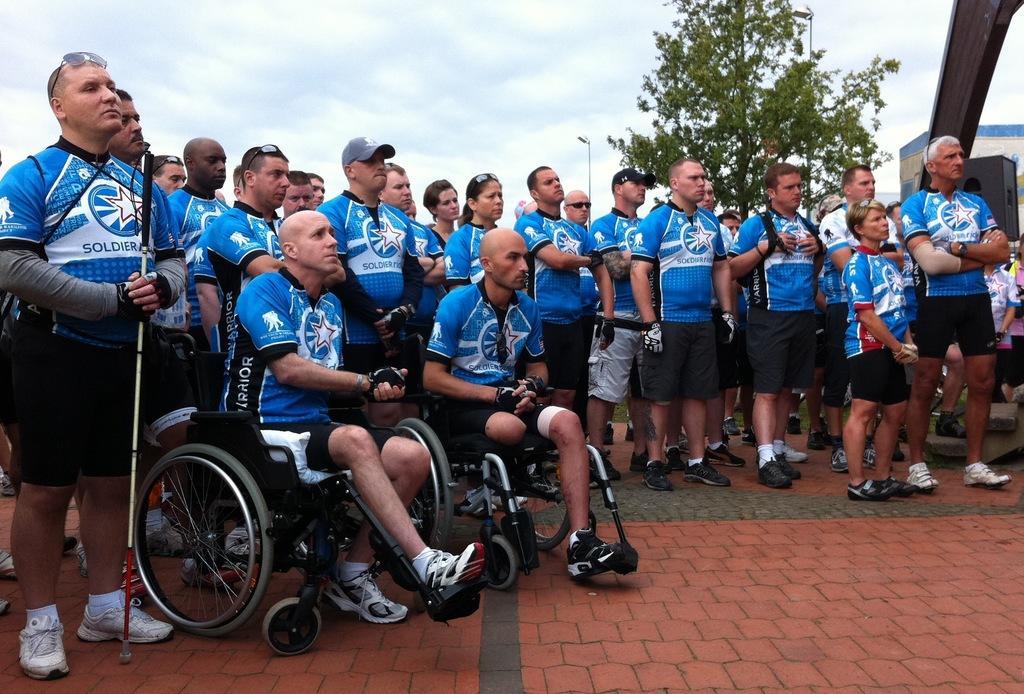How would you summarize this image in a sentence or two? In this image I can see few people are standing and few are sitting on the wheel chair. One person is holding stick and they are wearing blue and black color dresses. Back I can see trees,light pole and sky is in blue and white color. 